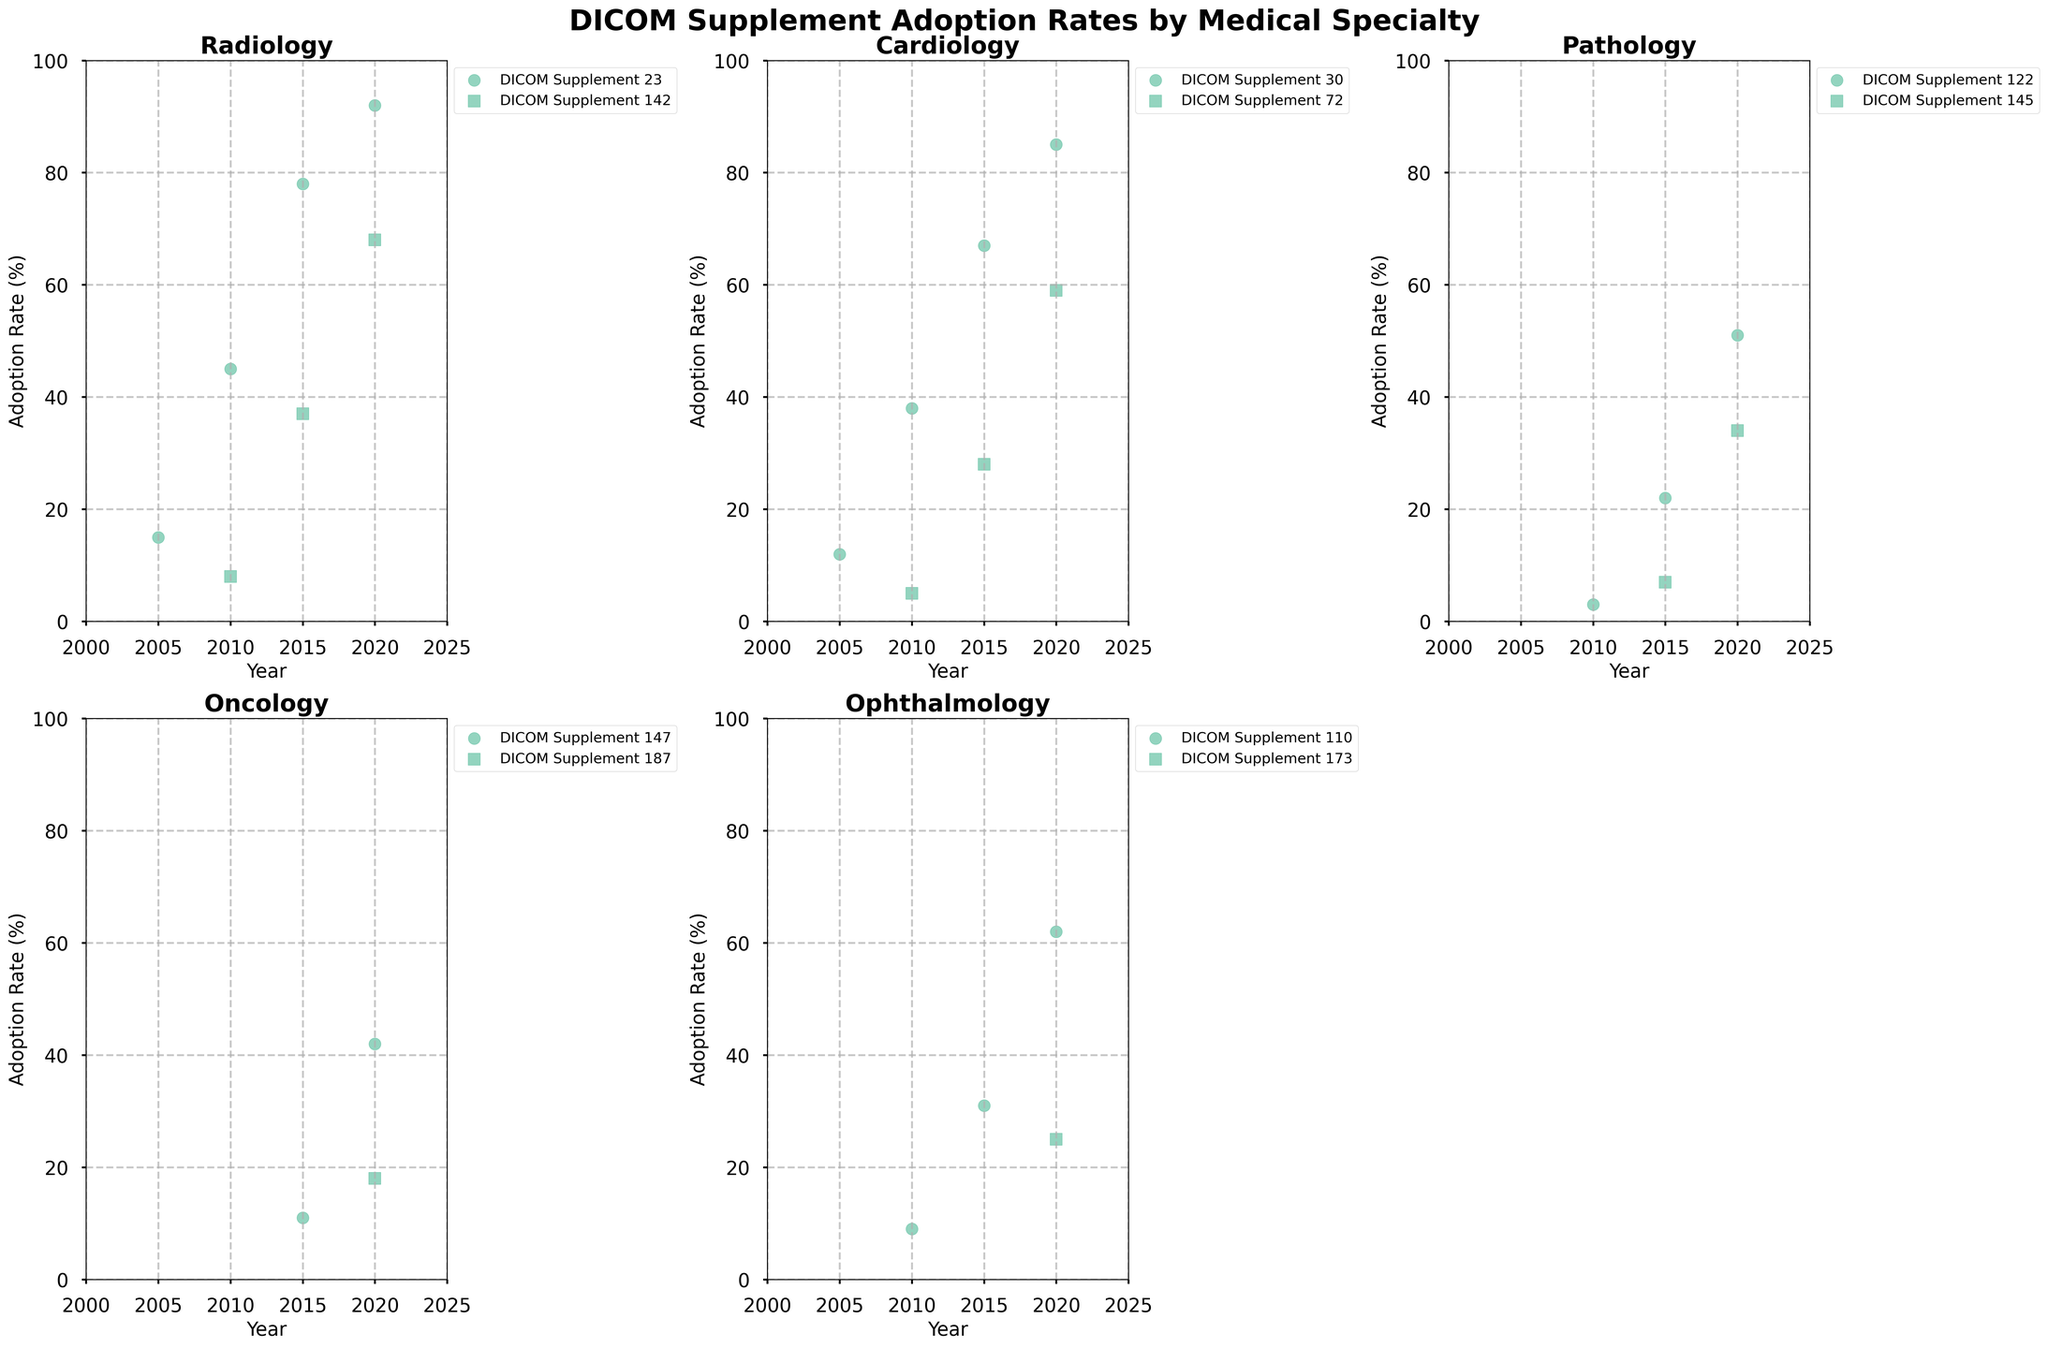What's the adoption rate of DICOM Supplement 23 in Radiology in 2015? Look at the scatter plot for Radiology, find the DICOM Supplement 23 data point for the year 2015. Read the corresponding adoption rate value.
Answer: 78 Which specialty has the highest adoption rate for any DICOM supplement in 2020? Compare the adoption rates for all specialties in 2020. For Radiology, DICOM Supplement 23 has an adoption rate of 92%. Verify this against other specialties in 2020.
Answer: Radiology What is the difference in adoption rates for DICOM Supplement 30 in Cardiology between 2010 and 2020? Look at the scatter plot for Cardiology. Find the adoption rates for DICOM Supplement 30 in 2010 (38%) and 2020 (85%). Subtract the 2010 value from the 2020 value: 85 - 38.
Answer: 47 What is the average adoption rate for DICOM Supplement 110 in Ophthalmology from 2010 to 2020? Look at the adoption rates for DICOM Supplement 110 in Ophthalmology for the years 2010 (9%), 2015 (31%), and 2020 (62%). Calculate the average: (9 + 31 + 62) / 3.
Answer: 34 Which supplement in Pathology saw the greatest increase in adoption rate between its first and last data points? Compare the increases for DICOM Supplement 122 (3% in 2010 to 51% in 2020) and DICOM Supplement 145 (7% in 2015 to 34% in 2020). The increase for Supplement 122 is 48 (51-3), and for Supplement 145, it is 27 (34-7). The greater increase is for Supplement 122.
Answer: DICOM Supplement 122 How does the adoption rate of DICOM Supplement 147 in Oncology in 2020 compare to its adoption rate in 2015? Look at the scatter plot for Oncology. For DICOM Supplement 147, the adoption rate in 2015 is 11% and in 2020 it is 42%. Compare these values: 42% is higher than 11%.
Answer: Higher in 2020 Which specialty shows the most consistent increase in adoption rates across all its supplements from the initial year to 2020? Examine the slopes of the adoption rates for each specialty's supplements. Radiology shows consistent increases for both DICOM Supplement 23 (15% to 92%) and DICOM Supplement 142 (8% to 68%). Compare with other specialties.
Answer: Radiology What is the total number of data points for the adoption rates in Ophthalmology? Count the number of entries for Ophthalmology in the scatter plot legend and data table. DICOM Supplement 110 has 3 data points and DICOM Supplement 173 has 1 data point. Sum them up: 3 + 1.
Answer: 4 Did any of the specialties reach a 100% adoption rate for any supplement by 2020? Check the highest adoption rates in the scatter plots for each specialty until 2020. No adoption rate reaches 100%.
Answer: No 